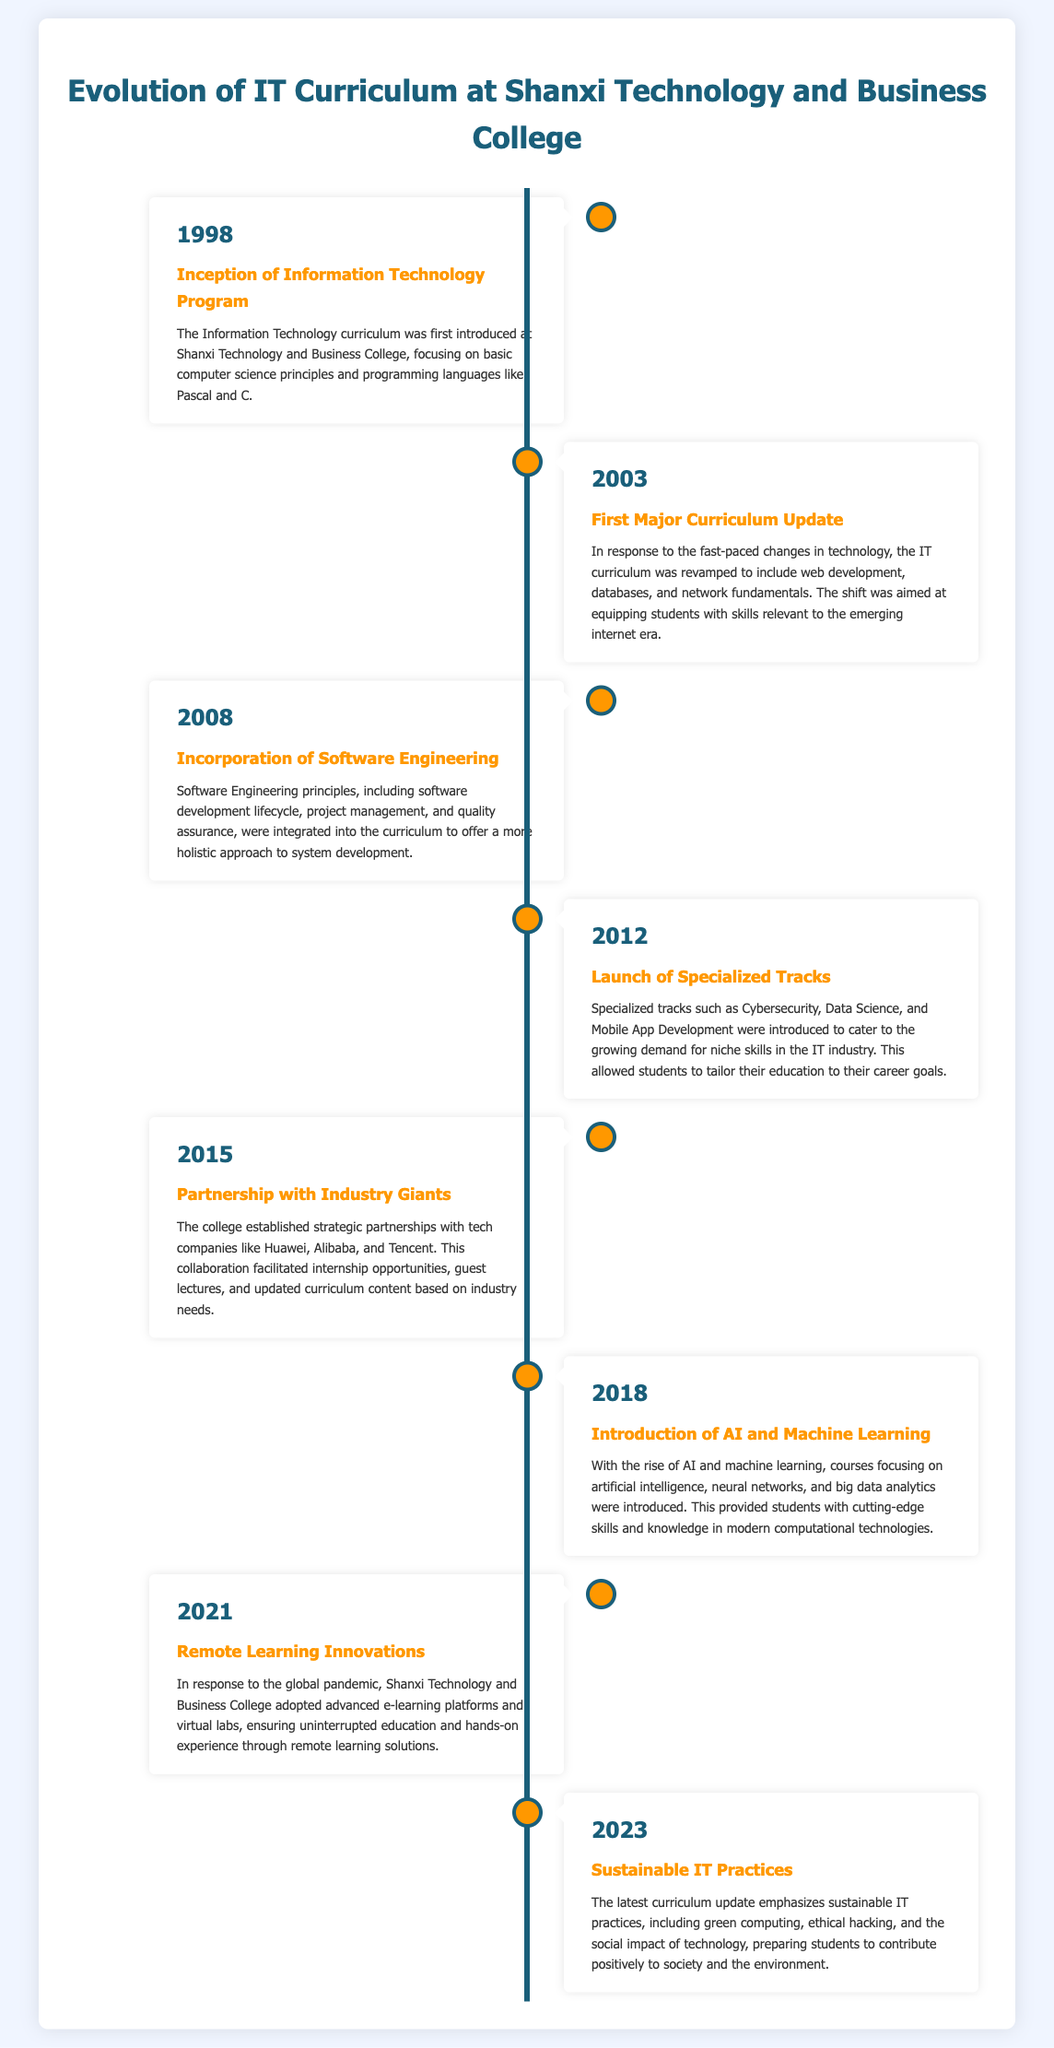What year was the Information Technology program first introduced? The document states that the program was introduced in the year 1998.
Answer: 1998 Which companies did Shanxi Technology and Business College partner with in 2015? The document mentions strategic partnerships with tech companies like Huawei, Alibaba, and Tencent.
Answer: Huawei, Alibaba, Tencent What was the major update introduced in 2003? The document indicates that the IT curriculum was revamped to include web development, databases, and network fundamentals.
Answer: Web development, databases, network fundamentals How many specialized tracks were launched in 2012? The document specifies that multiple specialized tracks, including Cybersecurity, Data Science, and Mobile App Development, were introduced, but does not provide a specific number.
Answer: Multiple What is a focus area of the 2023 curriculum update? The document highlights that the latest update emphasizes sustainable IT practices, including green computing and ethical hacking.
Answer: Sustainable IT practices In what year were courses on AI and Machine Learning introduced? According to the document, courses focusing on AI and Machine Learning were introduced in 2018.
Answer: 2018 What could be a reason for incorporating Software Engineering in 2008? The document suggests that it offered a more holistic approach to system development, integrating software development lifecycle and project management.
Answer: Holistic approach to system development What kind of innovations were adopted in education in 2021? The document states that advanced e-learning platforms and virtual labs were adopted for remote learning.
Answer: E-learning platforms and virtual labs 